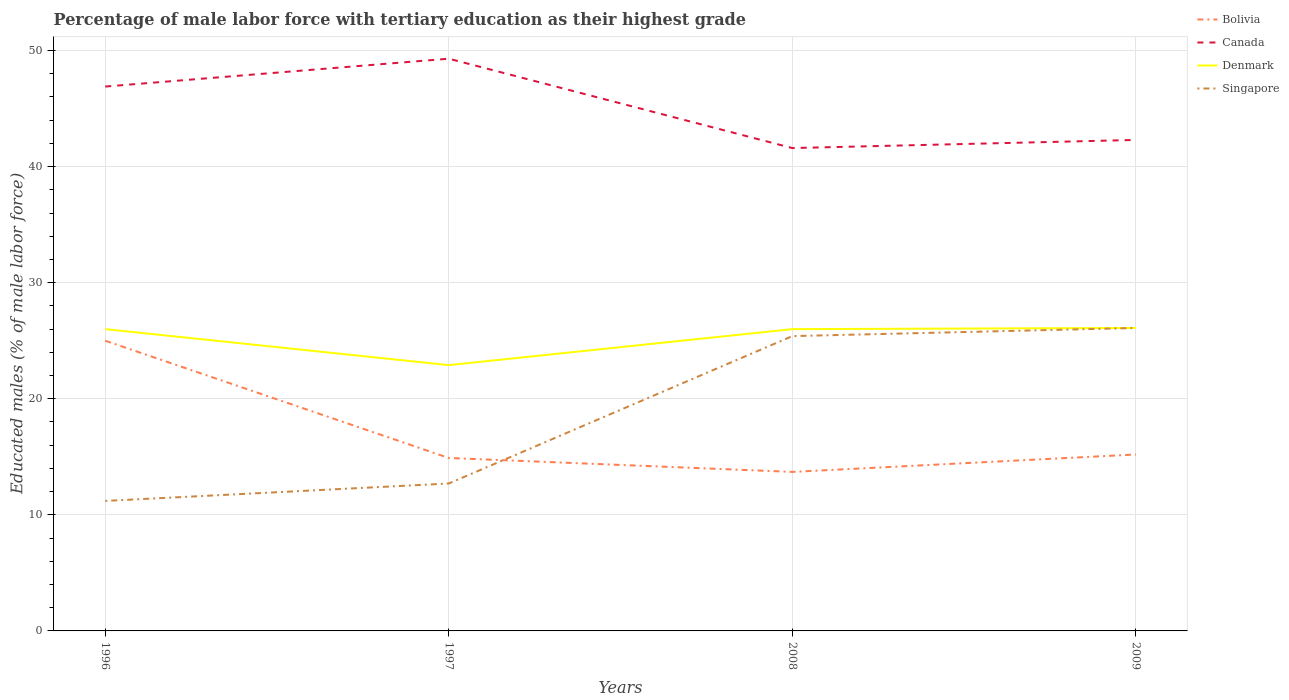How many different coloured lines are there?
Give a very brief answer. 4. Does the line corresponding to Canada intersect with the line corresponding to Denmark?
Make the answer very short. No. Across all years, what is the maximum percentage of male labor force with tertiary education in Singapore?
Make the answer very short. 11.2. In which year was the percentage of male labor force with tertiary education in Denmark maximum?
Your answer should be very brief. 1997. What is the total percentage of male labor force with tertiary education in Bolivia in the graph?
Your answer should be compact. 9.8. What is the difference between the highest and the second highest percentage of male labor force with tertiary education in Bolivia?
Your response must be concise. 11.3. What is the difference between the highest and the lowest percentage of male labor force with tertiary education in Bolivia?
Provide a short and direct response. 1. How many lines are there?
Your answer should be very brief. 4. What is the difference between two consecutive major ticks on the Y-axis?
Ensure brevity in your answer.  10. Does the graph contain any zero values?
Keep it short and to the point. No. How many legend labels are there?
Offer a terse response. 4. How are the legend labels stacked?
Offer a very short reply. Vertical. What is the title of the graph?
Make the answer very short. Percentage of male labor force with tertiary education as their highest grade. Does "Libya" appear as one of the legend labels in the graph?
Offer a very short reply. No. What is the label or title of the Y-axis?
Ensure brevity in your answer.  Educated males (% of male labor force). What is the Educated males (% of male labor force) in Canada in 1996?
Offer a terse response. 46.9. What is the Educated males (% of male labor force) in Denmark in 1996?
Provide a succinct answer. 26. What is the Educated males (% of male labor force) of Singapore in 1996?
Offer a very short reply. 11.2. What is the Educated males (% of male labor force) in Bolivia in 1997?
Offer a very short reply. 14.9. What is the Educated males (% of male labor force) of Canada in 1997?
Keep it short and to the point. 49.3. What is the Educated males (% of male labor force) of Denmark in 1997?
Your answer should be very brief. 22.9. What is the Educated males (% of male labor force) in Singapore in 1997?
Your answer should be very brief. 12.7. What is the Educated males (% of male labor force) of Bolivia in 2008?
Your response must be concise. 13.7. What is the Educated males (% of male labor force) of Canada in 2008?
Make the answer very short. 41.6. What is the Educated males (% of male labor force) of Singapore in 2008?
Provide a succinct answer. 25.4. What is the Educated males (% of male labor force) of Bolivia in 2009?
Make the answer very short. 15.2. What is the Educated males (% of male labor force) of Canada in 2009?
Provide a succinct answer. 42.3. What is the Educated males (% of male labor force) in Denmark in 2009?
Provide a short and direct response. 26.1. What is the Educated males (% of male labor force) of Singapore in 2009?
Your answer should be compact. 26.1. Across all years, what is the maximum Educated males (% of male labor force) of Bolivia?
Make the answer very short. 25. Across all years, what is the maximum Educated males (% of male labor force) of Canada?
Keep it short and to the point. 49.3. Across all years, what is the maximum Educated males (% of male labor force) of Denmark?
Your answer should be compact. 26.1. Across all years, what is the maximum Educated males (% of male labor force) of Singapore?
Keep it short and to the point. 26.1. Across all years, what is the minimum Educated males (% of male labor force) of Bolivia?
Give a very brief answer. 13.7. Across all years, what is the minimum Educated males (% of male labor force) in Canada?
Provide a short and direct response. 41.6. Across all years, what is the minimum Educated males (% of male labor force) in Denmark?
Provide a short and direct response. 22.9. Across all years, what is the minimum Educated males (% of male labor force) in Singapore?
Provide a succinct answer. 11.2. What is the total Educated males (% of male labor force) of Bolivia in the graph?
Make the answer very short. 68.8. What is the total Educated males (% of male labor force) in Canada in the graph?
Your response must be concise. 180.1. What is the total Educated males (% of male labor force) in Denmark in the graph?
Provide a succinct answer. 101. What is the total Educated males (% of male labor force) of Singapore in the graph?
Offer a terse response. 75.4. What is the difference between the Educated males (% of male labor force) in Bolivia in 1996 and that in 1997?
Provide a succinct answer. 10.1. What is the difference between the Educated males (% of male labor force) in Canada in 1996 and that in 1997?
Make the answer very short. -2.4. What is the difference between the Educated males (% of male labor force) of Canada in 1996 and that in 2008?
Provide a short and direct response. 5.3. What is the difference between the Educated males (% of male labor force) of Denmark in 1996 and that in 2008?
Make the answer very short. 0. What is the difference between the Educated males (% of male labor force) of Singapore in 1996 and that in 2008?
Your answer should be compact. -14.2. What is the difference between the Educated males (% of male labor force) in Bolivia in 1996 and that in 2009?
Your response must be concise. 9.8. What is the difference between the Educated males (% of male labor force) in Singapore in 1996 and that in 2009?
Offer a terse response. -14.9. What is the difference between the Educated males (% of male labor force) in Canada in 1997 and that in 2009?
Give a very brief answer. 7. What is the difference between the Educated males (% of male labor force) in Denmark in 1997 and that in 2009?
Offer a terse response. -3.2. What is the difference between the Educated males (% of male labor force) of Singapore in 1997 and that in 2009?
Offer a very short reply. -13.4. What is the difference between the Educated males (% of male labor force) in Bolivia in 2008 and that in 2009?
Provide a succinct answer. -1.5. What is the difference between the Educated males (% of male labor force) in Canada in 2008 and that in 2009?
Provide a succinct answer. -0.7. What is the difference between the Educated males (% of male labor force) of Denmark in 2008 and that in 2009?
Make the answer very short. -0.1. What is the difference between the Educated males (% of male labor force) of Bolivia in 1996 and the Educated males (% of male labor force) of Canada in 1997?
Your answer should be compact. -24.3. What is the difference between the Educated males (% of male labor force) in Canada in 1996 and the Educated males (% of male labor force) in Denmark in 1997?
Keep it short and to the point. 24. What is the difference between the Educated males (% of male labor force) in Canada in 1996 and the Educated males (% of male labor force) in Singapore in 1997?
Offer a terse response. 34.2. What is the difference between the Educated males (% of male labor force) in Bolivia in 1996 and the Educated males (% of male labor force) in Canada in 2008?
Give a very brief answer. -16.6. What is the difference between the Educated males (% of male labor force) of Bolivia in 1996 and the Educated males (% of male labor force) of Denmark in 2008?
Provide a short and direct response. -1. What is the difference between the Educated males (% of male labor force) in Canada in 1996 and the Educated males (% of male labor force) in Denmark in 2008?
Your response must be concise. 20.9. What is the difference between the Educated males (% of male labor force) of Bolivia in 1996 and the Educated males (% of male labor force) of Canada in 2009?
Your answer should be compact. -17.3. What is the difference between the Educated males (% of male labor force) of Bolivia in 1996 and the Educated males (% of male labor force) of Denmark in 2009?
Offer a very short reply. -1.1. What is the difference between the Educated males (% of male labor force) in Canada in 1996 and the Educated males (% of male labor force) in Denmark in 2009?
Make the answer very short. 20.8. What is the difference between the Educated males (% of male labor force) of Canada in 1996 and the Educated males (% of male labor force) of Singapore in 2009?
Keep it short and to the point. 20.8. What is the difference between the Educated males (% of male labor force) of Denmark in 1996 and the Educated males (% of male labor force) of Singapore in 2009?
Offer a very short reply. -0.1. What is the difference between the Educated males (% of male labor force) of Bolivia in 1997 and the Educated males (% of male labor force) of Canada in 2008?
Keep it short and to the point. -26.7. What is the difference between the Educated males (% of male labor force) of Bolivia in 1997 and the Educated males (% of male labor force) of Denmark in 2008?
Give a very brief answer. -11.1. What is the difference between the Educated males (% of male labor force) of Bolivia in 1997 and the Educated males (% of male labor force) of Singapore in 2008?
Make the answer very short. -10.5. What is the difference between the Educated males (% of male labor force) of Canada in 1997 and the Educated males (% of male labor force) of Denmark in 2008?
Keep it short and to the point. 23.3. What is the difference between the Educated males (% of male labor force) in Canada in 1997 and the Educated males (% of male labor force) in Singapore in 2008?
Keep it short and to the point. 23.9. What is the difference between the Educated males (% of male labor force) of Denmark in 1997 and the Educated males (% of male labor force) of Singapore in 2008?
Offer a terse response. -2.5. What is the difference between the Educated males (% of male labor force) in Bolivia in 1997 and the Educated males (% of male labor force) in Canada in 2009?
Provide a short and direct response. -27.4. What is the difference between the Educated males (% of male labor force) of Bolivia in 1997 and the Educated males (% of male labor force) of Denmark in 2009?
Provide a succinct answer. -11.2. What is the difference between the Educated males (% of male labor force) in Bolivia in 1997 and the Educated males (% of male labor force) in Singapore in 2009?
Keep it short and to the point. -11.2. What is the difference between the Educated males (% of male labor force) in Canada in 1997 and the Educated males (% of male labor force) in Denmark in 2009?
Offer a very short reply. 23.2. What is the difference between the Educated males (% of male labor force) in Canada in 1997 and the Educated males (% of male labor force) in Singapore in 2009?
Make the answer very short. 23.2. What is the difference between the Educated males (% of male labor force) in Bolivia in 2008 and the Educated males (% of male labor force) in Canada in 2009?
Offer a very short reply. -28.6. What is the difference between the Educated males (% of male labor force) in Bolivia in 2008 and the Educated males (% of male labor force) in Denmark in 2009?
Your answer should be compact. -12.4. What is the difference between the Educated males (% of male labor force) of Bolivia in 2008 and the Educated males (% of male labor force) of Singapore in 2009?
Make the answer very short. -12.4. What is the difference between the Educated males (% of male labor force) in Canada in 2008 and the Educated males (% of male labor force) in Denmark in 2009?
Your answer should be very brief. 15.5. What is the difference between the Educated males (% of male labor force) in Canada in 2008 and the Educated males (% of male labor force) in Singapore in 2009?
Offer a terse response. 15.5. What is the difference between the Educated males (% of male labor force) of Denmark in 2008 and the Educated males (% of male labor force) of Singapore in 2009?
Keep it short and to the point. -0.1. What is the average Educated males (% of male labor force) in Bolivia per year?
Provide a succinct answer. 17.2. What is the average Educated males (% of male labor force) in Canada per year?
Offer a very short reply. 45.02. What is the average Educated males (% of male labor force) in Denmark per year?
Offer a very short reply. 25.25. What is the average Educated males (% of male labor force) in Singapore per year?
Offer a very short reply. 18.85. In the year 1996, what is the difference between the Educated males (% of male labor force) of Bolivia and Educated males (% of male labor force) of Canada?
Provide a short and direct response. -21.9. In the year 1996, what is the difference between the Educated males (% of male labor force) of Bolivia and Educated males (% of male labor force) of Denmark?
Give a very brief answer. -1. In the year 1996, what is the difference between the Educated males (% of male labor force) in Bolivia and Educated males (% of male labor force) in Singapore?
Ensure brevity in your answer.  13.8. In the year 1996, what is the difference between the Educated males (% of male labor force) in Canada and Educated males (% of male labor force) in Denmark?
Your answer should be compact. 20.9. In the year 1996, what is the difference between the Educated males (% of male labor force) of Canada and Educated males (% of male labor force) of Singapore?
Make the answer very short. 35.7. In the year 1996, what is the difference between the Educated males (% of male labor force) of Denmark and Educated males (% of male labor force) of Singapore?
Provide a short and direct response. 14.8. In the year 1997, what is the difference between the Educated males (% of male labor force) of Bolivia and Educated males (% of male labor force) of Canada?
Offer a very short reply. -34.4. In the year 1997, what is the difference between the Educated males (% of male labor force) of Bolivia and Educated males (% of male labor force) of Singapore?
Give a very brief answer. 2.2. In the year 1997, what is the difference between the Educated males (% of male labor force) of Canada and Educated males (% of male labor force) of Denmark?
Offer a very short reply. 26.4. In the year 1997, what is the difference between the Educated males (% of male labor force) of Canada and Educated males (% of male labor force) of Singapore?
Provide a succinct answer. 36.6. In the year 2008, what is the difference between the Educated males (% of male labor force) in Bolivia and Educated males (% of male labor force) in Canada?
Give a very brief answer. -27.9. In the year 2009, what is the difference between the Educated males (% of male labor force) in Bolivia and Educated males (% of male labor force) in Canada?
Your answer should be very brief. -27.1. In the year 2009, what is the difference between the Educated males (% of male labor force) in Canada and Educated males (% of male labor force) in Denmark?
Ensure brevity in your answer.  16.2. In the year 2009, what is the difference between the Educated males (% of male labor force) in Canada and Educated males (% of male labor force) in Singapore?
Offer a very short reply. 16.2. In the year 2009, what is the difference between the Educated males (% of male labor force) of Denmark and Educated males (% of male labor force) of Singapore?
Your answer should be very brief. 0. What is the ratio of the Educated males (% of male labor force) of Bolivia in 1996 to that in 1997?
Provide a succinct answer. 1.68. What is the ratio of the Educated males (% of male labor force) of Canada in 1996 to that in 1997?
Offer a very short reply. 0.95. What is the ratio of the Educated males (% of male labor force) of Denmark in 1996 to that in 1997?
Provide a short and direct response. 1.14. What is the ratio of the Educated males (% of male labor force) of Singapore in 1996 to that in 1997?
Offer a terse response. 0.88. What is the ratio of the Educated males (% of male labor force) in Bolivia in 1996 to that in 2008?
Offer a terse response. 1.82. What is the ratio of the Educated males (% of male labor force) in Canada in 1996 to that in 2008?
Provide a short and direct response. 1.13. What is the ratio of the Educated males (% of male labor force) of Singapore in 1996 to that in 2008?
Ensure brevity in your answer.  0.44. What is the ratio of the Educated males (% of male labor force) of Bolivia in 1996 to that in 2009?
Offer a very short reply. 1.64. What is the ratio of the Educated males (% of male labor force) in Canada in 1996 to that in 2009?
Give a very brief answer. 1.11. What is the ratio of the Educated males (% of male labor force) of Singapore in 1996 to that in 2009?
Keep it short and to the point. 0.43. What is the ratio of the Educated males (% of male labor force) in Bolivia in 1997 to that in 2008?
Offer a terse response. 1.09. What is the ratio of the Educated males (% of male labor force) of Canada in 1997 to that in 2008?
Offer a terse response. 1.19. What is the ratio of the Educated males (% of male labor force) in Denmark in 1997 to that in 2008?
Give a very brief answer. 0.88. What is the ratio of the Educated males (% of male labor force) of Bolivia in 1997 to that in 2009?
Offer a very short reply. 0.98. What is the ratio of the Educated males (% of male labor force) in Canada in 1997 to that in 2009?
Provide a short and direct response. 1.17. What is the ratio of the Educated males (% of male labor force) in Denmark in 1997 to that in 2009?
Ensure brevity in your answer.  0.88. What is the ratio of the Educated males (% of male labor force) of Singapore in 1997 to that in 2009?
Make the answer very short. 0.49. What is the ratio of the Educated males (% of male labor force) in Bolivia in 2008 to that in 2009?
Provide a short and direct response. 0.9. What is the ratio of the Educated males (% of male labor force) of Canada in 2008 to that in 2009?
Keep it short and to the point. 0.98. What is the ratio of the Educated males (% of male labor force) of Singapore in 2008 to that in 2009?
Give a very brief answer. 0.97. What is the difference between the highest and the second highest Educated males (% of male labor force) in Bolivia?
Offer a terse response. 9.8. What is the difference between the highest and the second highest Educated males (% of male labor force) in Canada?
Offer a very short reply. 2.4. What is the difference between the highest and the second highest Educated males (% of male labor force) in Denmark?
Keep it short and to the point. 0.1. What is the difference between the highest and the second highest Educated males (% of male labor force) in Singapore?
Your answer should be very brief. 0.7. What is the difference between the highest and the lowest Educated males (% of male labor force) of Bolivia?
Your answer should be compact. 11.3. What is the difference between the highest and the lowest Educated males (% of male labor force) of Canada?
Provide a short and direct response. 7.7. What is the difference between the highest and the lowest Educated males (% of male labor force) in Singapore?
Give a very brief answer. 14.9. 